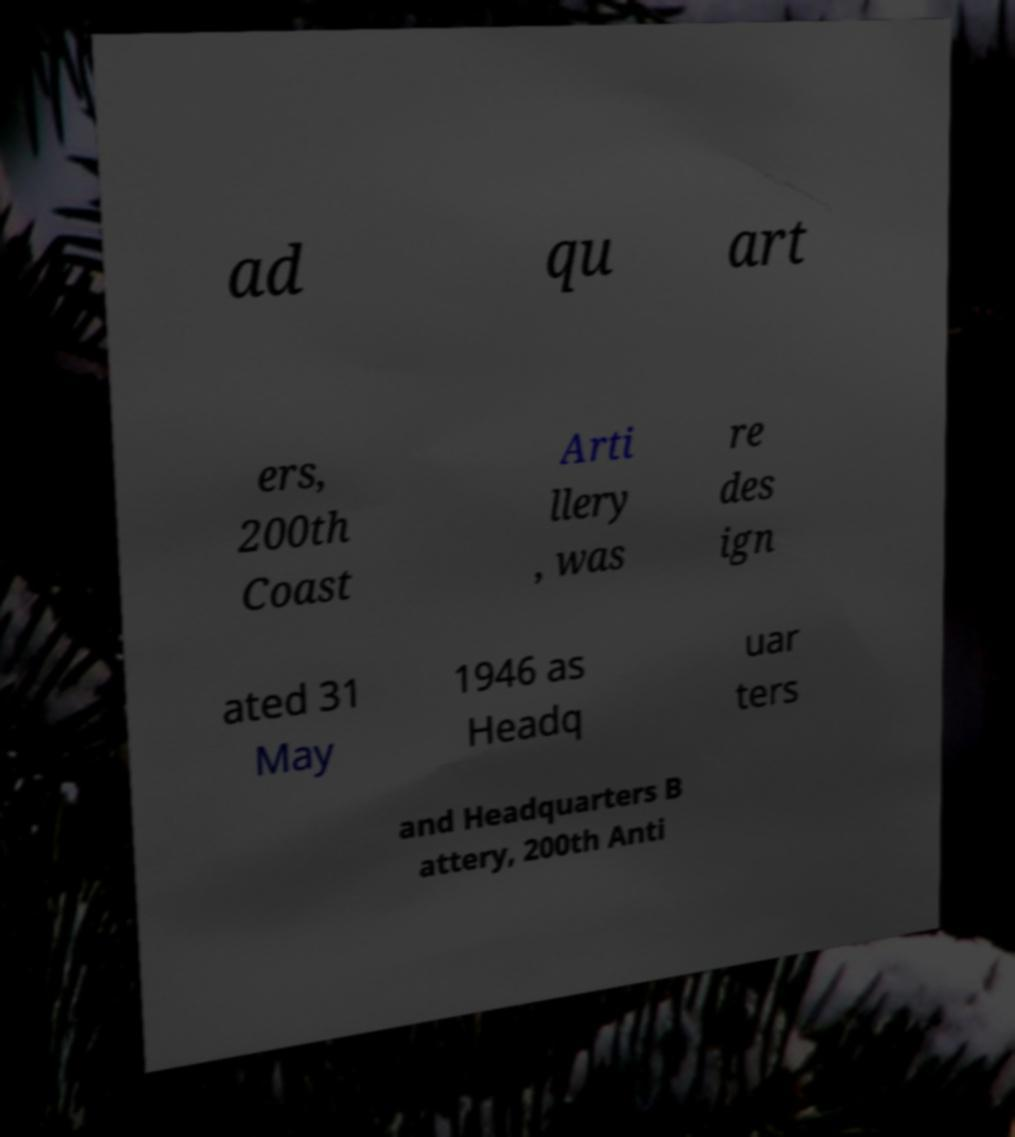Please identify and transcribe the text found in this image. ad qu art ers, 200th Coast Arti llery , was re des ign ated 31 May 1946 as Headq uar ters and Headquarters B attery, 200th Anti 